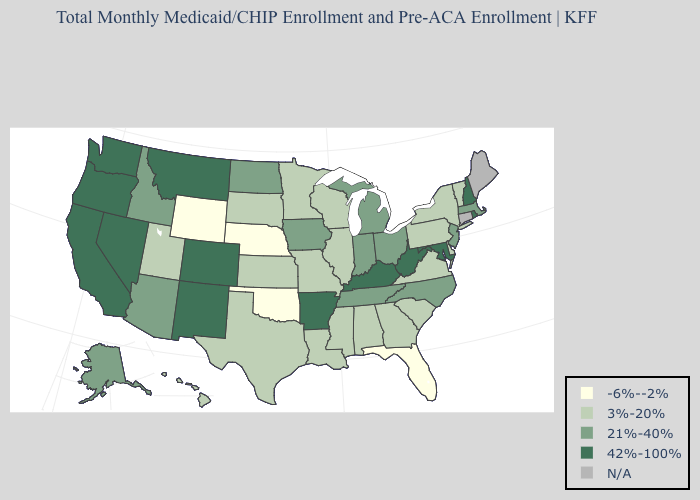Name the states that have a value in the range 3%-20%?
Quick response, please. Alabama, Delaware, Georgia, Hawaii, Illinois, Kansas, Louisiana, Minnesota, Mississippi, Missouri, New York, Pennsylvania, South Carolina, South Dakota, Texas, Utah, Vermont, Virginia, Wisconsin. What is the value of New Hampshire?
Write a very short answer. 42%-100%. Which states have the lowest value in the South?
Concise answer only. Florida, Oklahoma. Name the states that have a value in the range 21%-40%?
Write a very short answer. Alaska, Arizona, Idaho, Indiana, Iowa, Massachusetts, Michigan, New Jersey, North Carolina, North Dakota, Ohio, Tennessee. Among the states that border Alabama , which have the highest value?
Write a very short answer. Tennessee. Name the states that have a value in the range 21%-40%?
Quick response, please. Alaska, Arizona, Idaho, Indiana, Iowa, Massachusetts, Michigan, New Jersey, North Carolina, North Dakota, Ohio, Tennessee. How many symbols are there in the legend?
Keep it brief. 5. What is the value of Oklahoma?
Answer briefly. -6%--2%. Does the first symbol in the legend represent the smallest category?
Concise answer only. Yes. Which states have the lowest value in the South?
Answer briefly. Florida, Oklahoma. Among the states that border South Carolina , which have the highest value?
Keep it brief. North Carolina. How many symbols are there in the legend?
Be succinct. 5. Is the legend a continuous bar?
Write a very short answer. No. Does Idaho have the highest value in the USA?
Be succinct. No. Among the states that border Virginia , which have the lowest value?
Write a very short answer. North Carolina, Tennessee. 